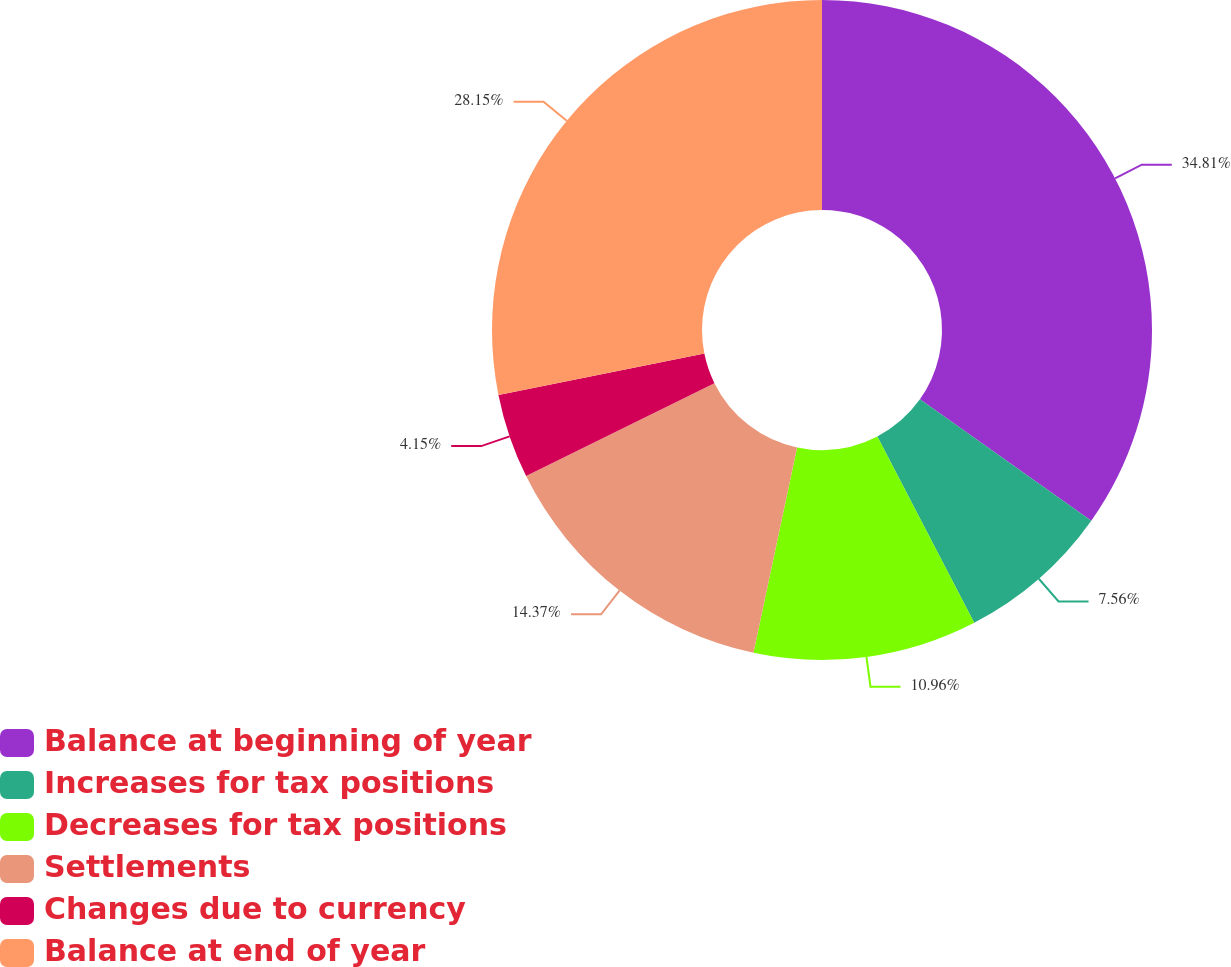Convert chart to OTSL. <chart><loc_0><loc_0><loc_500><loc_500><pie_chart><fcel>Balance at beginning of year<fcel>Increases for tax positions<fcel>Decreases for tax positions<fcel>Settlements<fcel>Changes due to currency<fcel>Balance at end of year<nl><fcel>34.81%<fcel>7.56%<fcel>10.96%<fcel>14.37%<fcel>4.15%<fcel>28.15%<nl></chart> 